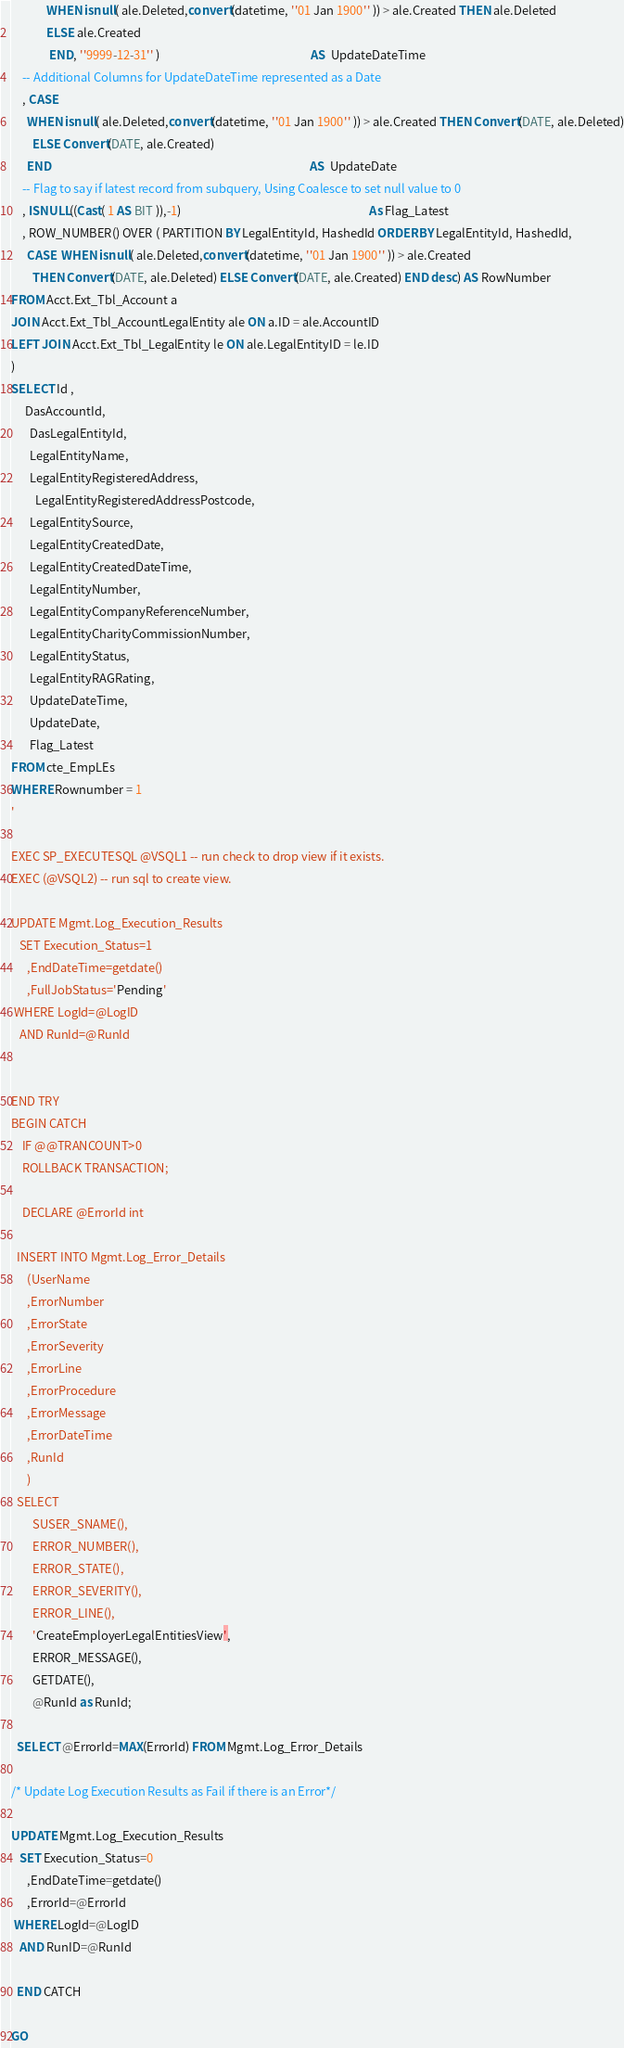<code> <loc_0><loc_0><loc_500><loc_500><_SQL_>             WHEN isnull( ale.Deleted,convert(datetime, ''01 Jan 1900'' )) > ale.Created THEN ale.Deleted
	         ELSE ale.Created
	          END, ''9999-12-31'' )                                                        AS  UpdateDateTime
	-- Additional Columns for UpdateDateTime represented as a Date
	, CASE 
      WHEN isnull( ale.Deleted,convert(datetime, ''01 Jan 1900'' )) > ale.Created THEN Convert(DATE, ale.Deleted)
	    ELSE Convert(DATE, ale.Created)
	  END                                                                                                AS  UpdateDate
	-- Flag to say if latest record from subquery, Using Coalesce to set null value to 0
	, ISNULL((Cast( 1 AS BIT )),-1)                                                                      As Flag_Latest
	, ROW_NUMBER() OVER ( PARTITION BY LegalEntityId, HashedId ORDER BY LegalEntityId, HashedId, 
	  CASE  WHEN isnull( ale.Deleted,convert(datetime, ''01 Jan 1900'' )) > ale.Created 
		THEN Convert(DATE, ale.Deleted) ELSE Convert(DATE, ale.Created) END desc) AS RowNumber
FROM Acct.Ext_Tbl_Account a
JOIN Acct.Ext_Tbl_AccountLegalEntity ale ON a.ID = ale.AccountID
LEFT JOIN Acct.Ext_Tbl_LegalEntity le ON ale.LegalEntityID = le.ID
) 
SELECT Id ,
     DasAccountId,
	   DasLegalEntityId,
	   LegalEntityName,
	   LegalEntityRegisteredAddress,
		 LegalEntityRegisteredAddressPostcode,
	   LegalEntitySource,
	   LegalEntityCreatedDate,
	   LegalEntityCreatedDateTime,
	   LegalEntityNumber,
	   LegalEntityCompanyReferenceNumber,
	   LegalEntityCharityCommissionNumber,
	   LegalEntityStatus,
	   LegalEntityRAGRating,
	   UpdateDateTime,
	   UpdateDate,
	   Flag_Latest
FROM cte_EmpLEs 
WHERE Rownumber = 1
'

EXEC SP_EXECUTESQL @VSQL1 -- run check to drop view if it exists. 
EXEC (@VSQL2) -- run sql to create view. 

UPDATE Mgmt.Log_Execution_Results
   SET Execution_Status=1
      ,EndDateTime=getdate()
	  ,FullJobStatus='Pending'
 WHERE LogId=@LogID
   AND RunId=@RunId

 
END TRY
BEGIN CATCH
    IF @@TRANCOUNT>0
	ROLLBACK TRANSACTION;

    DECLARE @ErrorId int

  INSERT INTO Mgmt.Log_Error_Details
	  (UserName
	  ,ErrorNumber
	  ,ErrorState
	  ,ErrorSeverity
	  ,ErrorLine
	  ,ErrorProcedure
	  ,ErrorMessage
	  ,ErrorDateTime
	  ,RunId
	  )
  SELECT 
        SUSER_SNAME(),
	    ERROR_NUMBER(),
	    ERROR_STATE(),
	    ERROR_SEVERITY(),
	    ERROR_LINE(),
	    'CreateEmployerLegalEntitiesView',
	    ERROR_MESSAGE(),
	    GETDATE(),
		@RunId as RunId; 

  SELECT @ErrorId=MAX(ErrorId) FROM Mgmt.Log_Error_Details

/* Update Log Execution Results as Fail if there is an Error*/

UPDATE Mgmt.Log_Execution_Results
   SET Execution_Status=0
      ,EndDateTime=getdate()
	  ,ErrorId=@ErrorId
 WHERE LogId=@LogID
   AND RunID=@RunId

  END CATCH

GO
</code> 